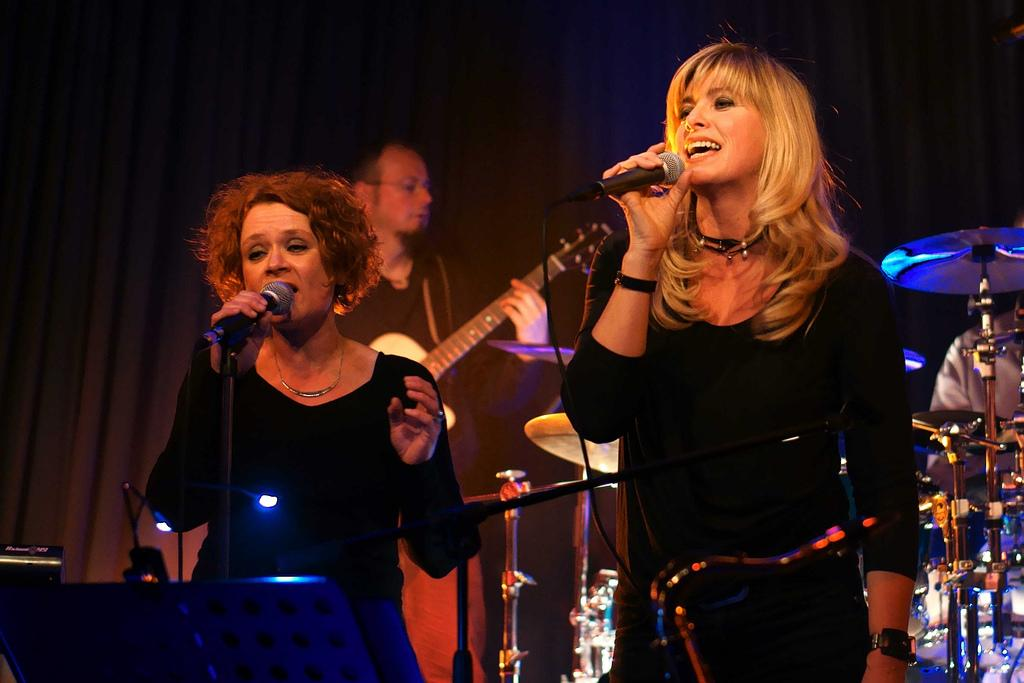How many people are in the image? There are three people in the image. What are two of the people doing? Two of the people are singing into a microphone. What instrument is one person playing? One person is playing a guitar. What other musical instrument can be seen in the image? There are musical drums on the right side of the image. What type of pet can be seen sitting on the faucet in the image? There is no pet or faucet present in the image; it features three people, two of whom are singing into a microphone, one playing a guitar, and musical drums on the right side. 